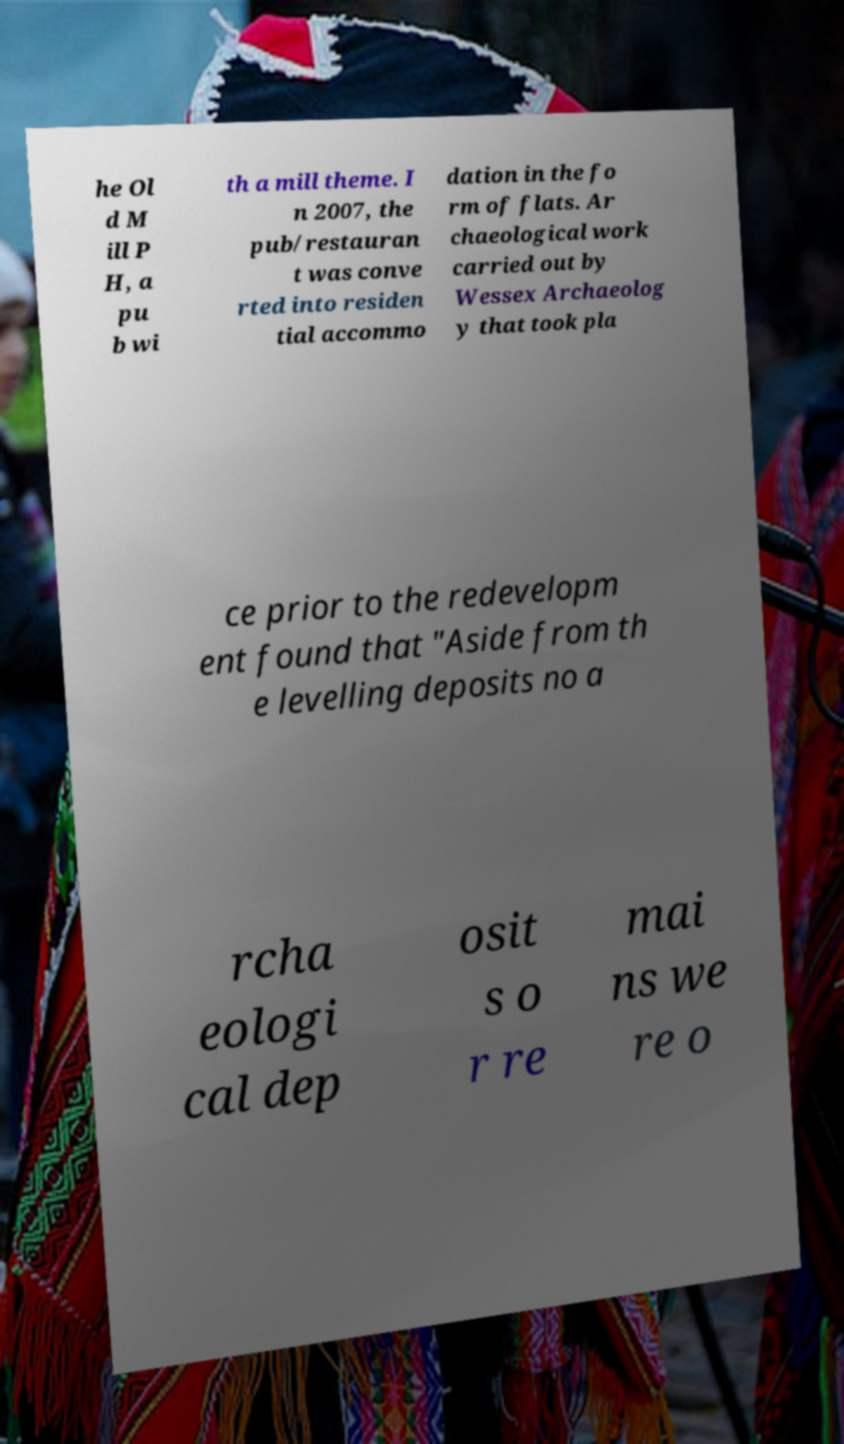I need the written content from this picture converted into text. Can you do that? he Ol d M ill P H, a pu b wi th a mill theme. I n 2007, the pub/restauran t was conve rted into residen tial accommo dation in the fo rm of flats. Ar chaeological work carried out by Wessex Archaeolog y that took pla ce prior to the redevelopm ent found that "Aside from th e levelling deposits no a rcha eologi cal dep osit s o r re mai ns we re o 